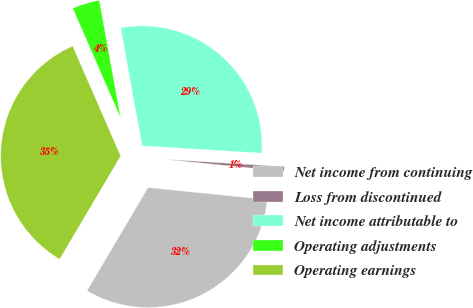<chart> <loc_0><loc_0><loc_500><loc_500><pie_chart><fcel>Net income from continuing<fcel>Loss from discontinued<fcel>Net income attributable to<fcel>Operating adjustments<fcel>Operating earnings<nl><fcel>31.89%<fcel>0.63%<fcel>28.83%<fcel>3.69%<fcel>34.95%<nl></chart> 